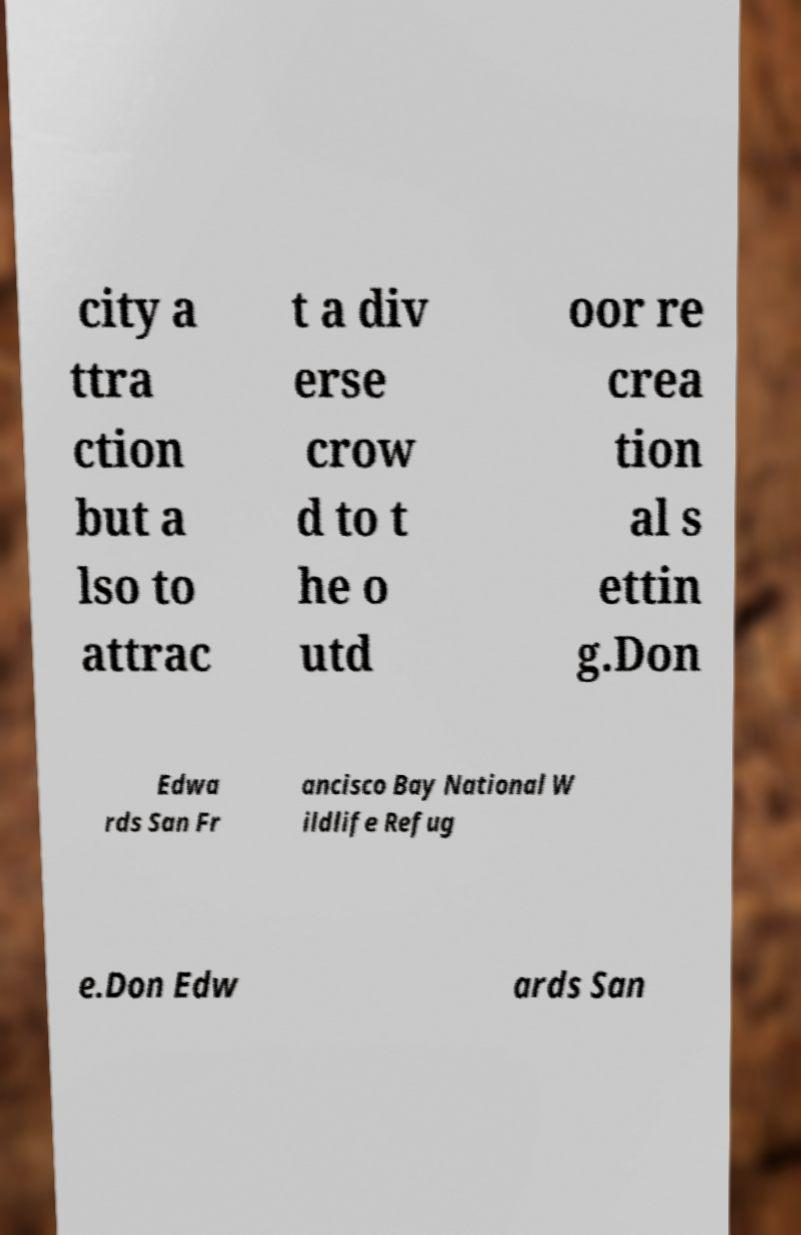Can you accurately transcribe the text from the provided image for me? city a ttra ction but a lso to attrac t a div erse crow d to t he o utd oor re crea tion al s ettin g.Don Edwa rds San Fr ancisco Bay National W ildlife Refug e.Don Edw ards San 